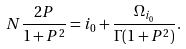<formula> <loc_0><loc_0><loc_500><loc_500>N \frac { 2 P } { 1 + P ^ { 2 } } = i _ { 0 } + \frac { \Omega _ { i _ { 0 } } } { \Gamma ( 1 + P ^ { 2 } ) } .</formula> 